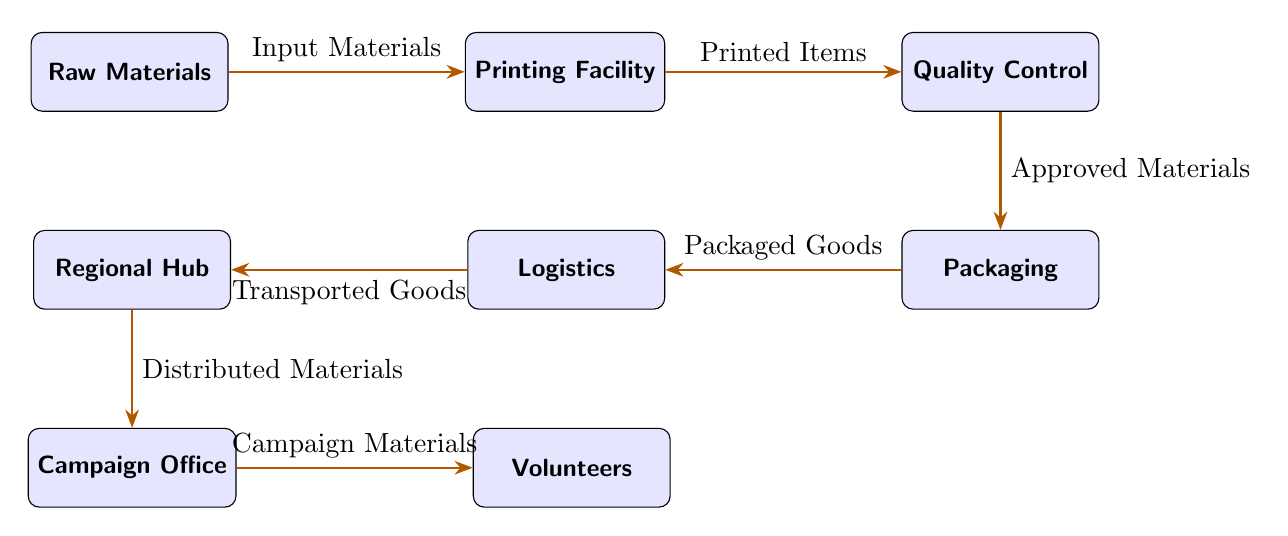What is the first node in the food chain? The first node in the food chain is "Raw Materials," which indicates the starting point for the campaign materials supply chain.
Answer: Raw Materials How many nodes are there in total? The diagram contains a total of 7 nodes representing different stages in the supply chain for campaign materials. These nodes include Raw Materials, Printing Facility, Quality Control, Packaging, Logistics, Regional Hub, Campaign Office, and Volunteers.
Answer: 7 Which node is responsible for packaging? "Packaging" is the node where the goods are packed after quality control. It is positioned below the Quality Control node in the diagram.
Answer: Packaging What is the last step before the campaign office? The last step before the Campaign Office is the "Regional Hub," which indicates that materials are distributed from this hub to the office.
Answer: Regional Hub How do packaged goods get to the regional hub? Packaged goods are transported to the Regional Hub through the "Logistics" node, which handles the transportation of goods.
Answer: Logistics What do volunteers receive in the supply chain? Volunteers receive "Campaign Materials," which are the final items distributed to them for campaigning purposes.
Answer: Campaign Materials How many steps are between raw materials and volunteers? There are 5 steps between "Raw Materials" and "Volunteers," which include Printing Facility, Quality Control, Packaging, Logistics, and Regional Hub.
Answer: 5 Which node comes directly after quality control? The node that comes directly after Quality Control is "Packaging," indicating that approved materials are promptly sent for packaging.
Answer: Packaging What does the logistics node represent? The Logistics node represents "Transported Goods," indicating the transport process of the packaged items before reaching the regional hub.
Answer: Transported Goods 